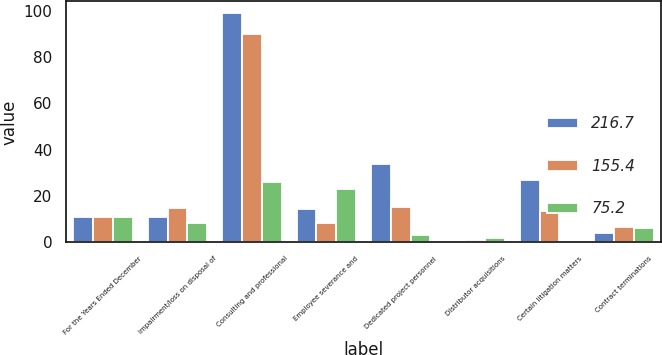Convert chart to OTSL. <chart><loc_0><loc_0><loc_500><loc_500><stacked_bar_chart><ecel><fcel>For the Years Ended December<fcel>Impairment/loss on disposal of<fcel>Consulting and professional<fcel>Employee severance and<fcel>Dedicated project personnel<fcel>Distributor acquisitions<fcel>Certain litigation matters<fcel>Contract terminations<nl><fcel>216.7<fcel>10.9<fcel>10.9<fcel>99.1<fcel>14.2<fcel>34<fcel>0.4<fcel>26.9<fcel>3.9<nl><fcel>155.4<fcel>10.9<fcel>14.6<fcel>90.1<fcel>8.2<fcel>15.1<fcel>0.8<fcel>13.7<fcel>6.6<nl><fcel>75.2<fcel>10.9<fcel>8.4<fcel>26<fcel>23.1<fcel>3.2<fcel>2<fcel>0.1<fcel>6.3<nl></chart> 